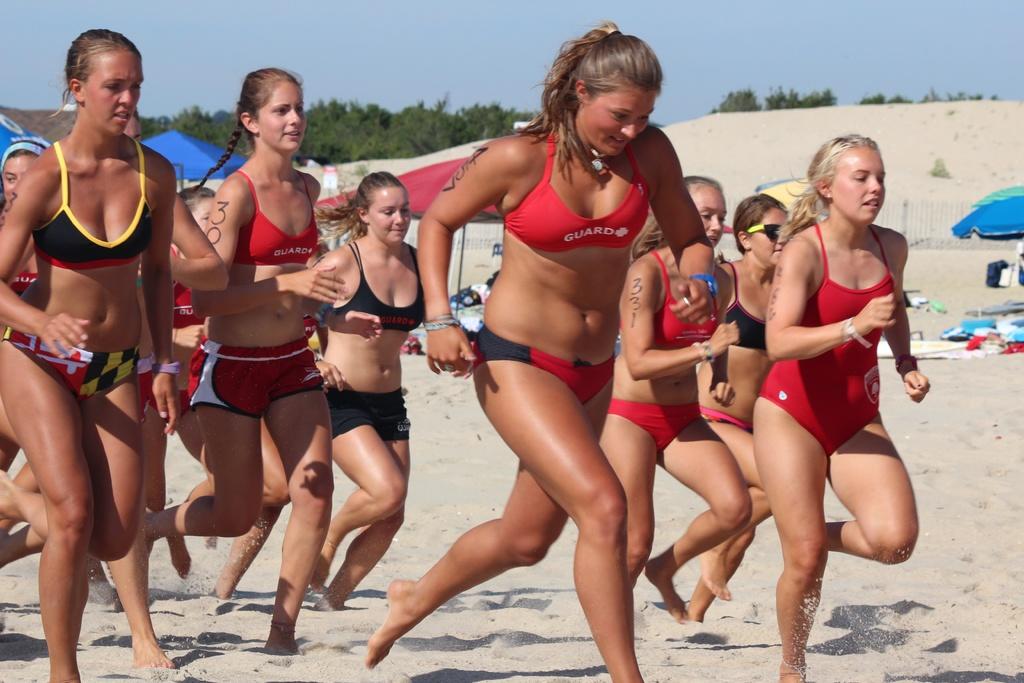What profession is the woman in the picture?
Provide a succinct answer. Guard. What does the bikini top say on it of the woman in front?
Your response must be concise. Guard. 